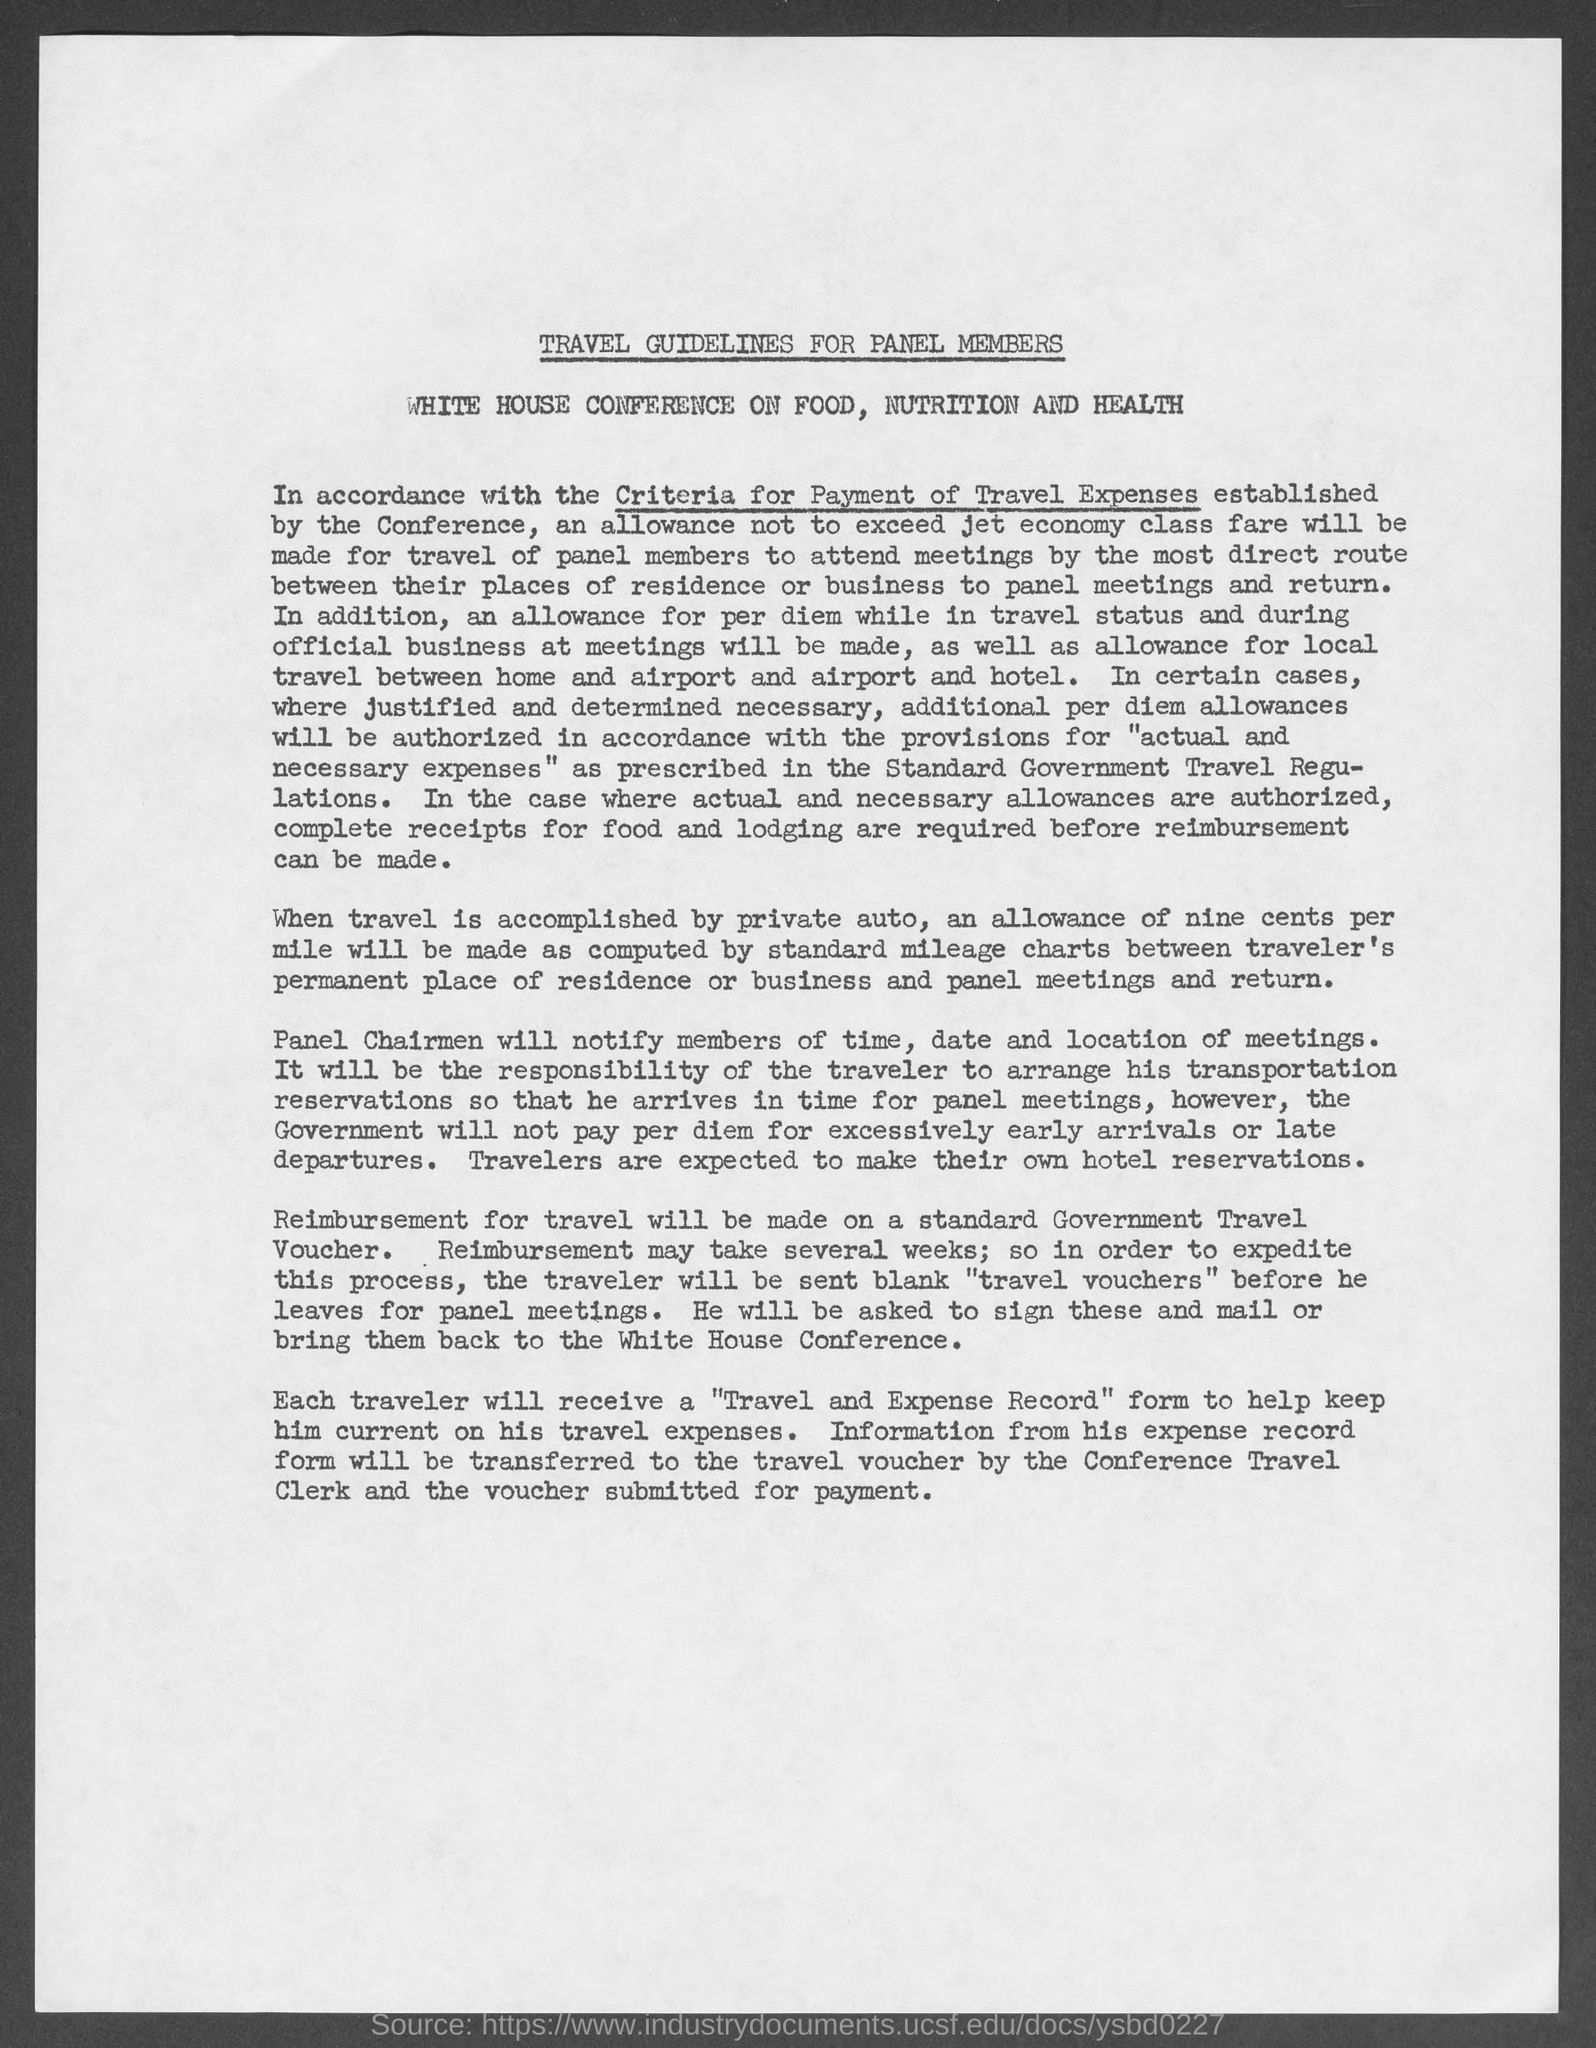Indicate a few pertinent items in this graphic. The reimbursement for travel will be made using standard government travel vouchers. When traveling by private auto, the allowance is nine cents per mile. The title of the document is 'Travel Guidelines for Panel Members.' The notification of the time, date, and location of meetings will be provided by the panel chairmen to the members. 